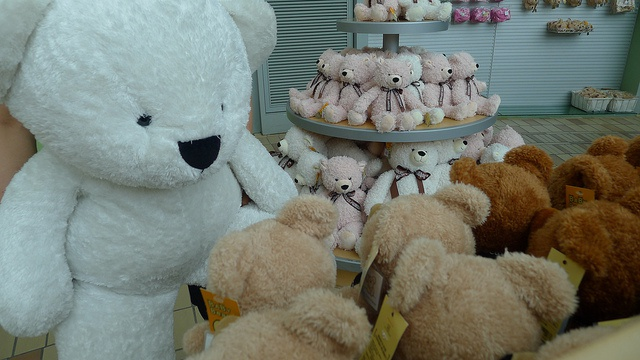Describe the objects in this image and their specific colors. I can see teddy bear in lightblue, darkgray, and gray tones, teddy bear in lightblue and gray tones, teddy bear in lightblue, gray, and olive tones, teddy bear in lightblue, darkgray, maroon, black, and olive tones, and teddy bear in lightblue, black, maroon, olive, and gray tones in this image. 